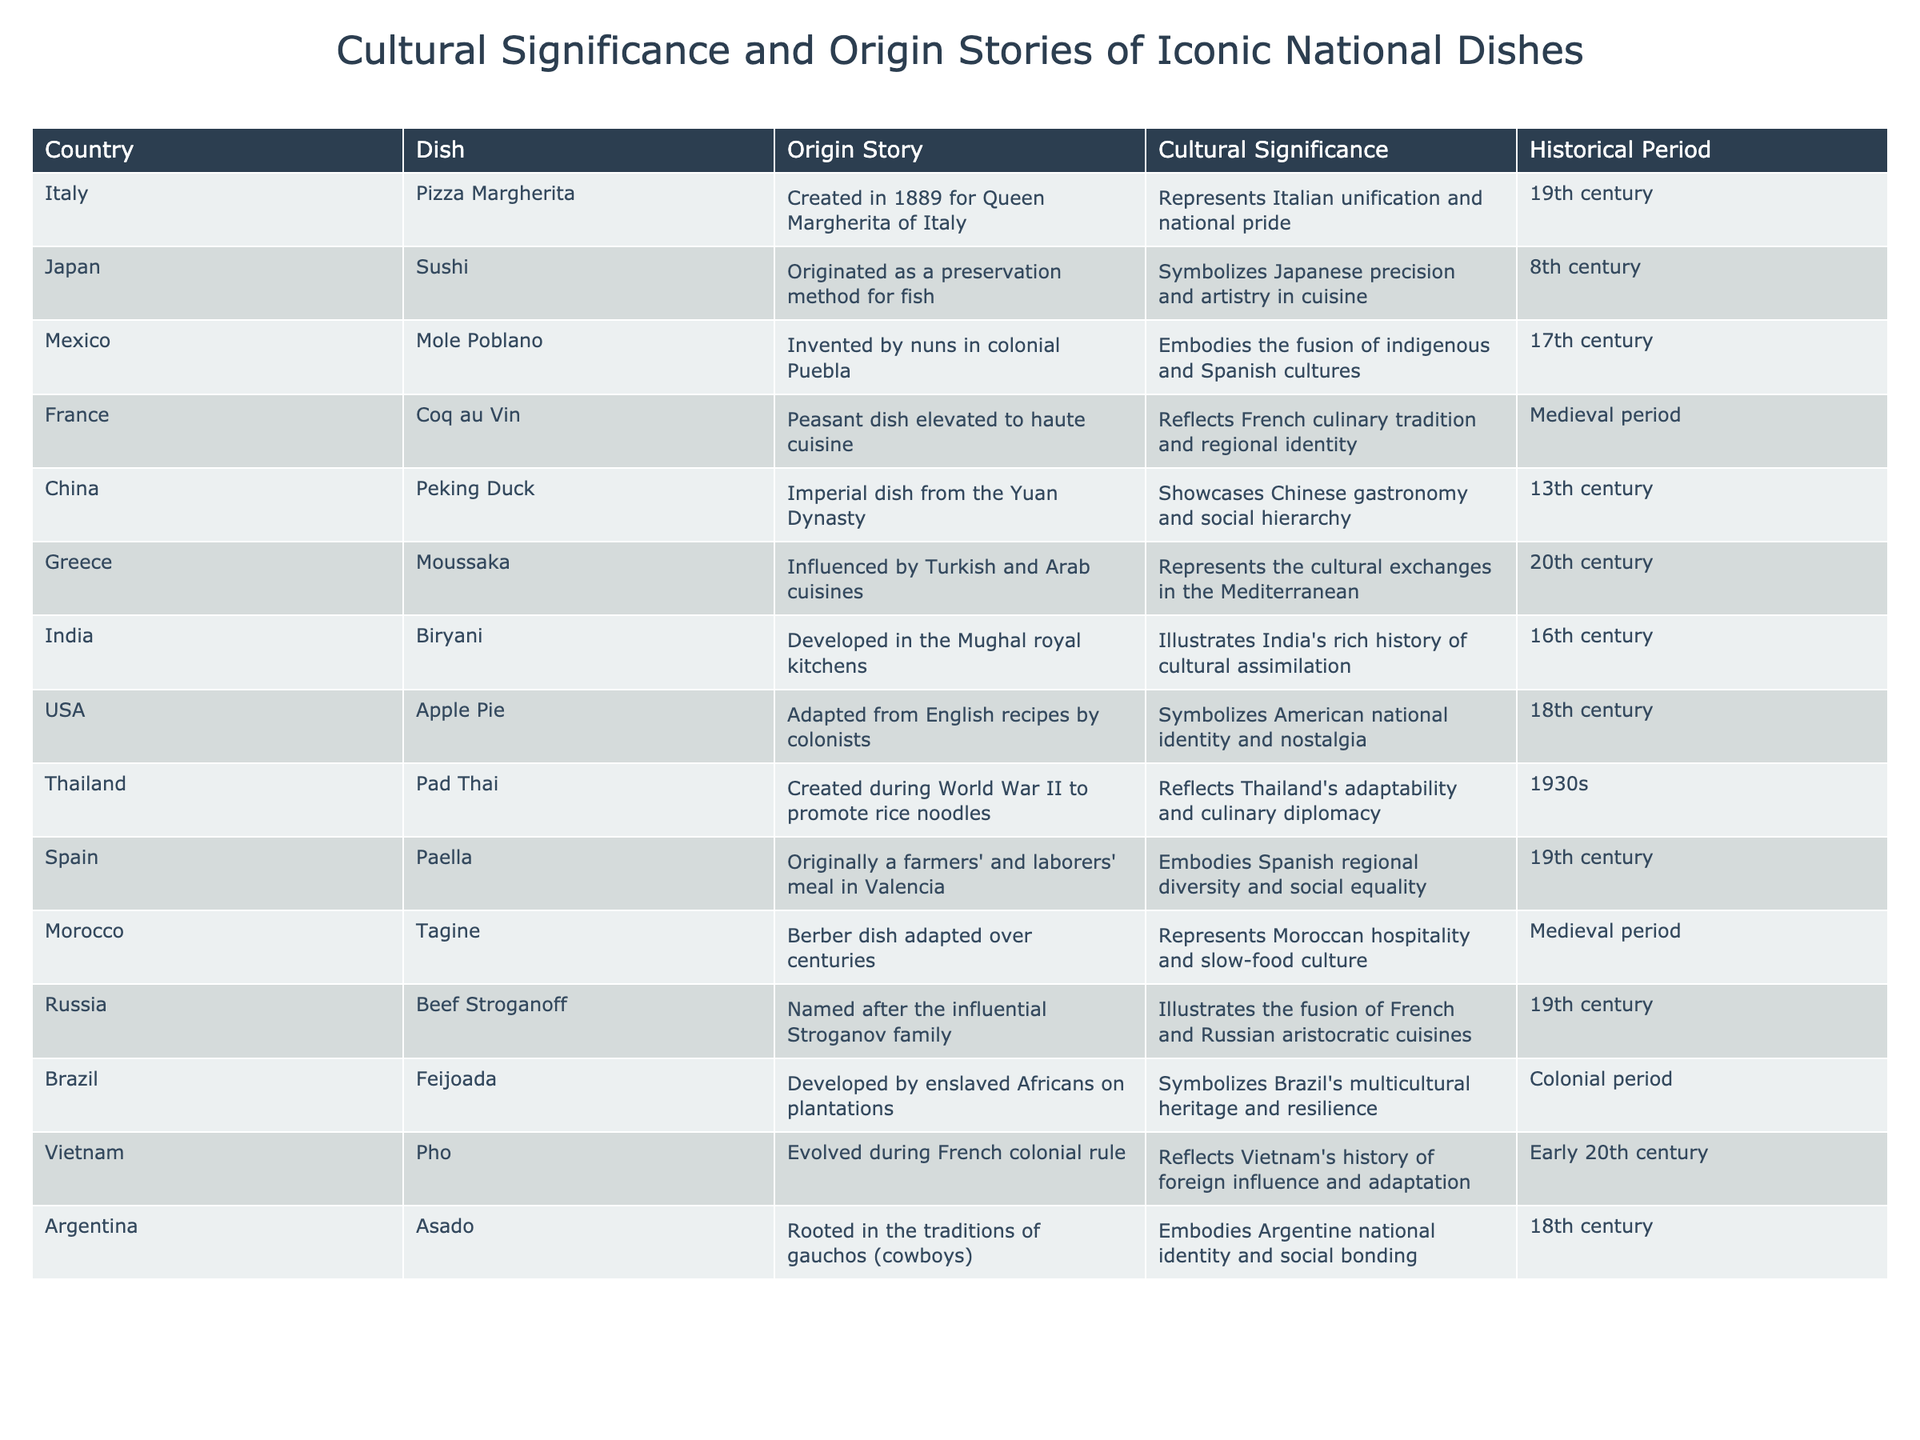What is the cultural significance of Mole Poblano? The cultural significance of Mole Poblano is that it embodies the fusion of indigenous and Spanish cultures, reflecting the blend of traditions in Mexico.
Answer: It embodies the fusion of indigenous and Spanish cultures Which dish was created for a queen in 1889? The dish created for a queen in 1889 is Pizza Margherita, made for Queen Margherita of Italy.
Answer: Pizza Margherita What is the historical period of Biryani? The historical period of Biryani is the 16th century, during which it was developed in the Mughal royal kitchens.
Answer: 16th century Is Pho a dish that evolved during colonial rule? Yes, Pho is a dish that evolved during French colonial rule in Vietnam.
Answer: Yes Which dishes were influenced by other cultures? Several dishes were influenced by other cultures, including Moussaka (Turkish and Arab), Mole Poblano (Spanish), and Pho (French).
Answer: Moussaka, Mole Poblano, Pho What represents Argentine national identity? Asado represents Argentine national identity and is rooted in the traditions of gauchos (cowboys).
Answer: Asado How many dishes originated in the 19th century? There are five dishes that originated in the 19th century: Pizza Margherita, Paella, Beef Stroganoff, and two others.
Answer: Five dishes What dish showcases Chinese gastronomy and social hierarchy? The dish that showcases Chinese gastronomy and social hierarchy is Peking Duck, which was an imperial dish from the Yuan Dynasty.
Answer: Peking Duck Which dish reflects Thailand's adaptability and culinary diplomacy? The dish that reflects Thailand's adaptability and culinary diplomacy is Pad Thai, created during World War II to promote rice noodles.
Answer: Pad Thai Is Beef Stroganoff a peasant dish? No, Beef Stroganoff is not a peasant dish; it illustrates the fusion of French and Russian aristocratic cuisines.
Answer: No 